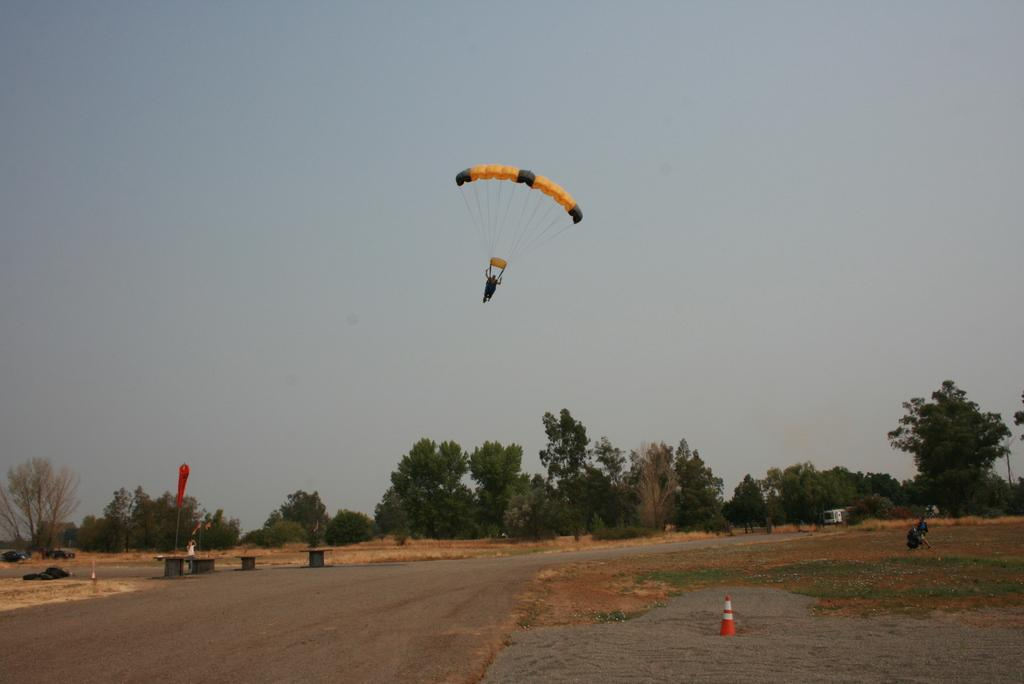What is the person in the image doing? The person is flying a parachute in the air. What can be seen on the ground in the image? There are trees on the surface, and a road surface is in front of the trees. What type of feast is being prepared in the trees? There is no mention of a feast or any preparation in the image; it only shows a person flying a parachute and trees on the ground. 